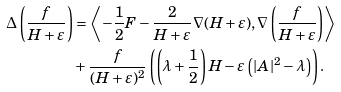Convert formula to latex. <formula><loc_0><loc_0><loc_500><loc_500>\Delta \left ( \frac { f } { H + \varepsilon } \right ) & = \left \langle - \frac { 1 } { 2 } F - \frac { 2 } { H + \varepsilon } \nabla ( H + \varepsilon ) , \nabla \left ( \frac { f } { H + \varepsilon } \right ) \right \rangle \\ & + \frac { f } { ( H + \varepsilon ) ^ { 2 } } \left ( \left ( \lambda + \frac { 1 } { 2 } \right ) H - \varepsilon \left ( | A | ^ { 2 } - \lambda \right ) \right ) .</formula> 